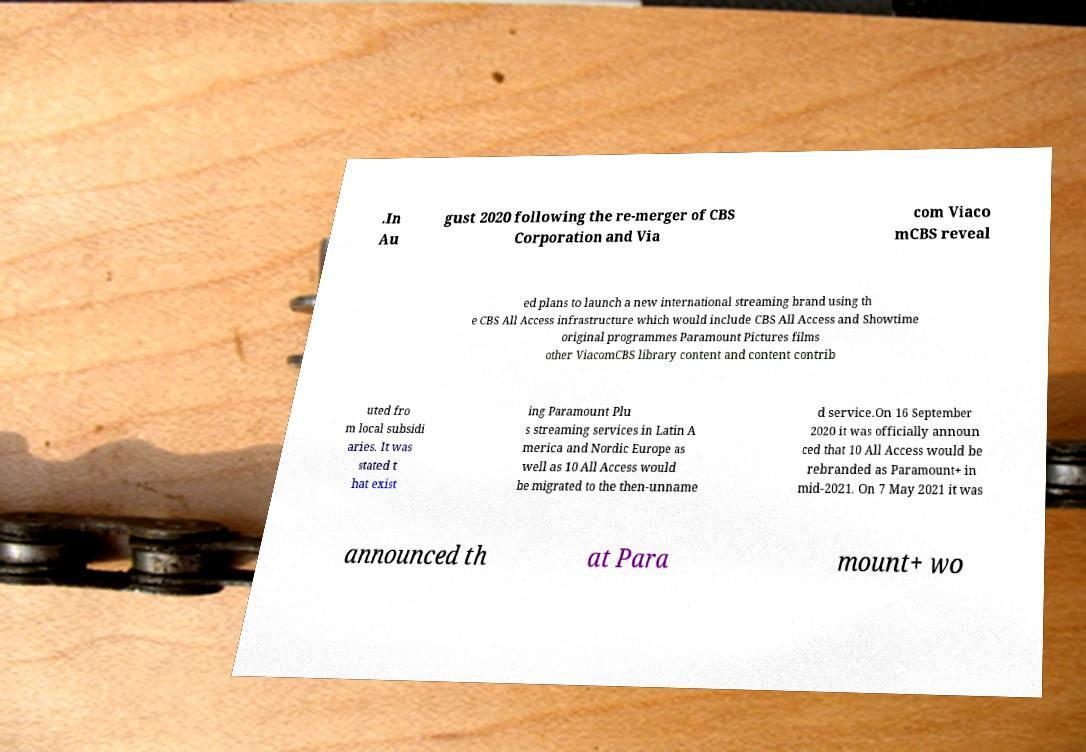Could you extract and type out the text from this image? .In Au gust 2020 following the re-merger of CBS Corporation and Via com Viaco mCBS reveal ed plans to launch a new international streaming brand using th e CBS All Access infrastructure which would include CBS All Access and Showtime original programmes Paramount Pictures films other ViacomCBS library content and content contrib uted fro m local subsidi aries. It was stated t hat exist ing Paramount Plu s streaming services in Latin A merica and Nordic Europe as well as 10 All Access would be migrated to the then-unname d service.On 16 September 2020 it was officially announ ced that 10 All Access would be rebranded as Paramount+ in mid-2021. On 7 May 2021 it was announced th at Para mount+ wo 